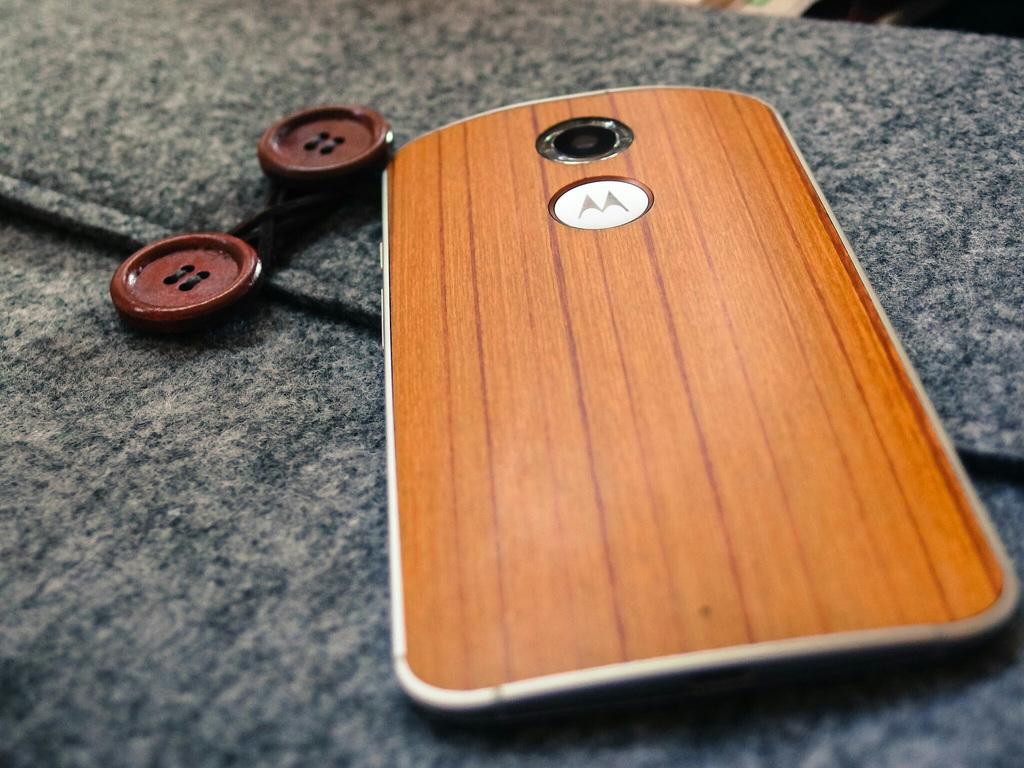What letter is on the back of this phone?
Keep it short and to the point. M. What brand is the device?
Your answer should be very brief. Motorola. 